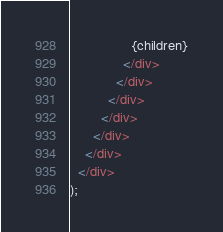<code> <loc_0><loc_0><loc_500><loc_500><_JavaScript_>                {children}
              </div>
            </div>
          </div>
        </div>
      </div>
    </div>
  </div>
);
</code> 